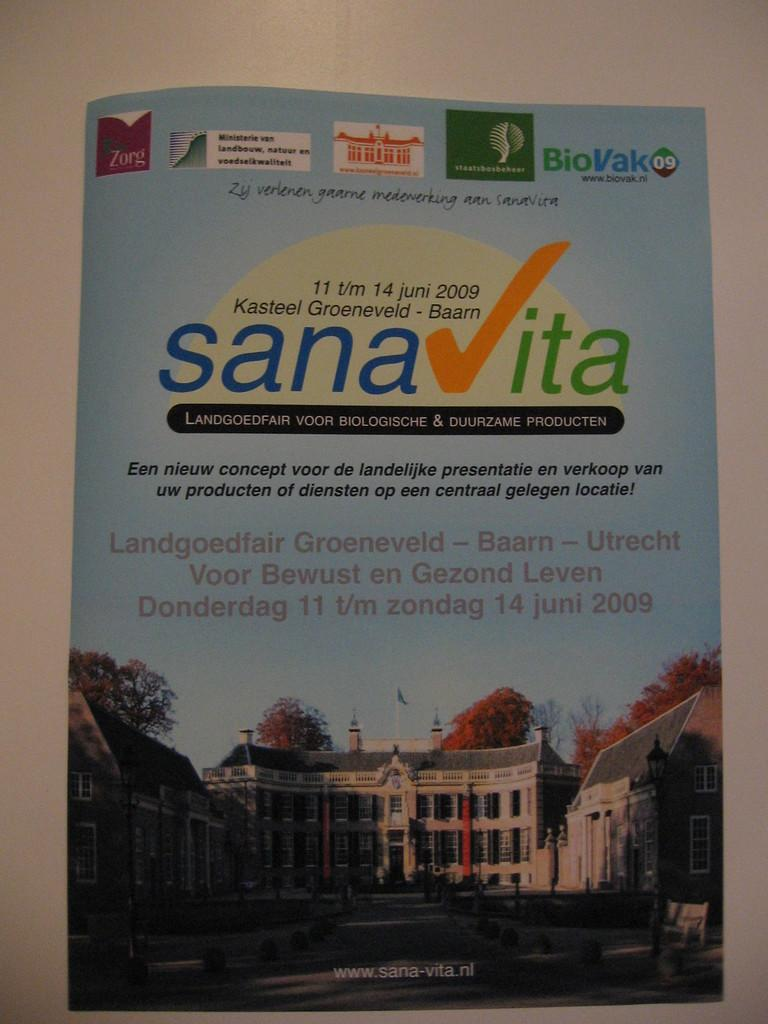<image>
Provide a brief description of the given image. Sana vita poster thatcontains information by Kasteel Groenveld 